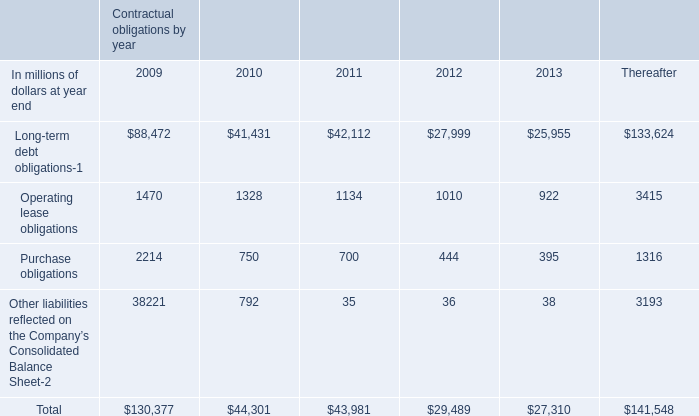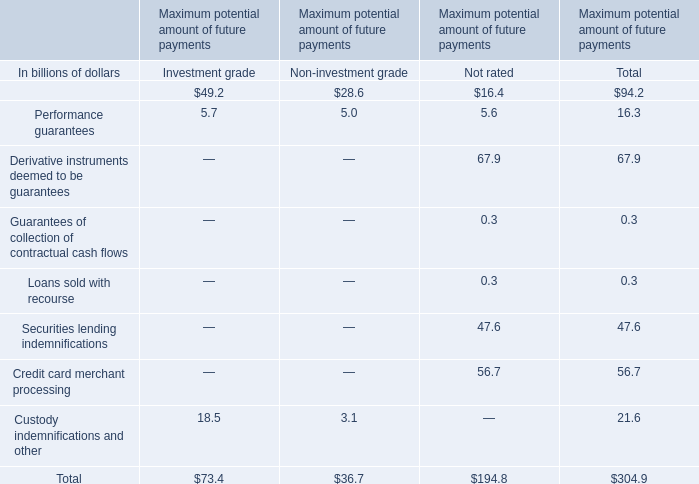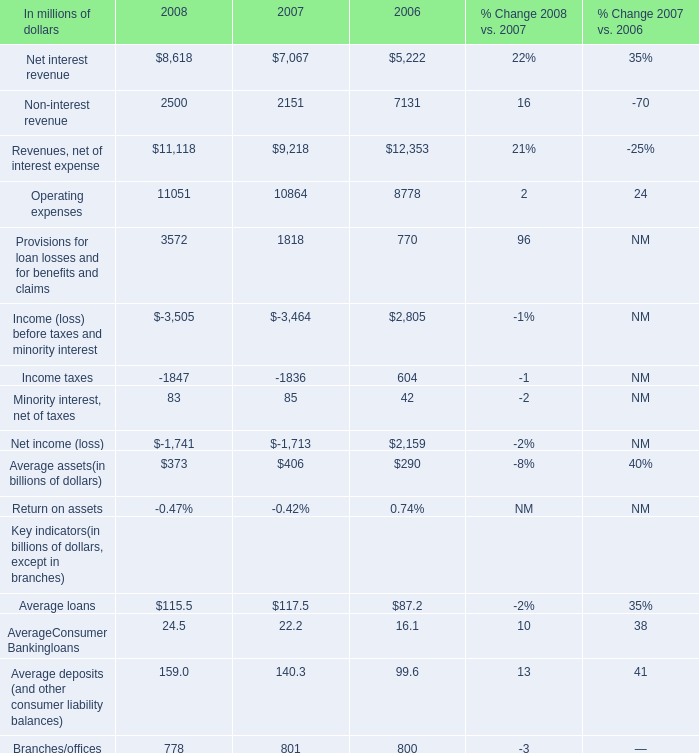What is the average amount of Income taxes of 2008, and Operating lease obligations of Contractual obligations by year 2009 ? 
Computations: ((1847.0 + 1470.0) / 2)
Answer: 1658.5. 